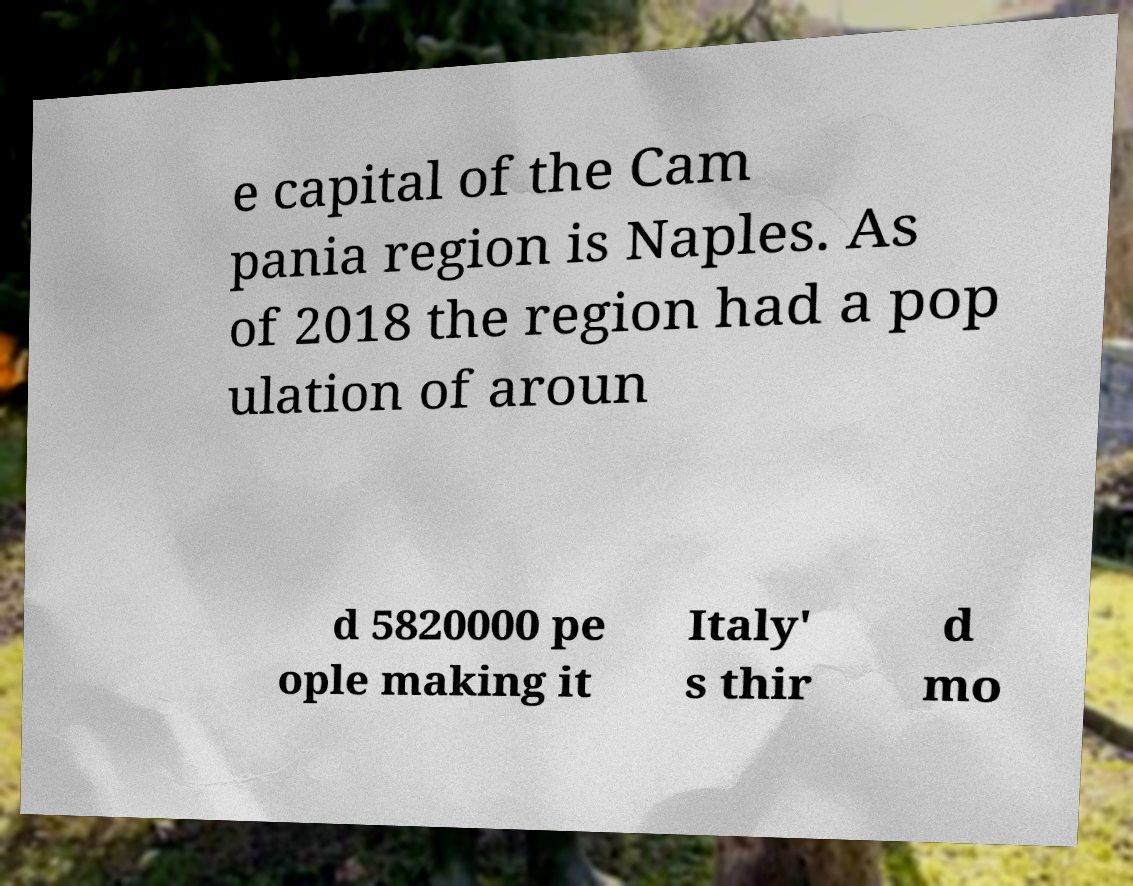Please identify and transcribe the text found in this image. e capital of the Cam pania region is Naples. As of 2018 the region had a pop ulation of aroun d 5820000 pe ople making it Italy' s thir d mo 